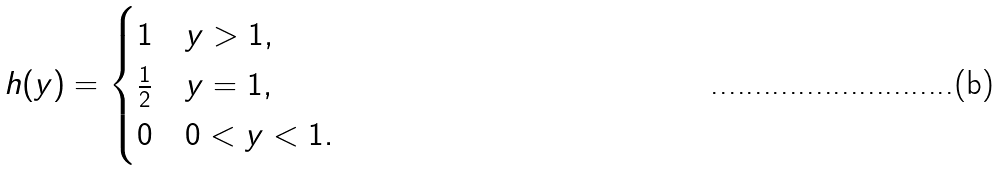Convert formula to latex. <formula><loc_0><loc_0><loc_500><loc_500>h ( y ) = \begin{cases} 1 & y > 1 , \\ \frac { 1 } { 2 } & y = 1 , \\ 0 & 0 < y < 1 . \end{cases}</formula> 